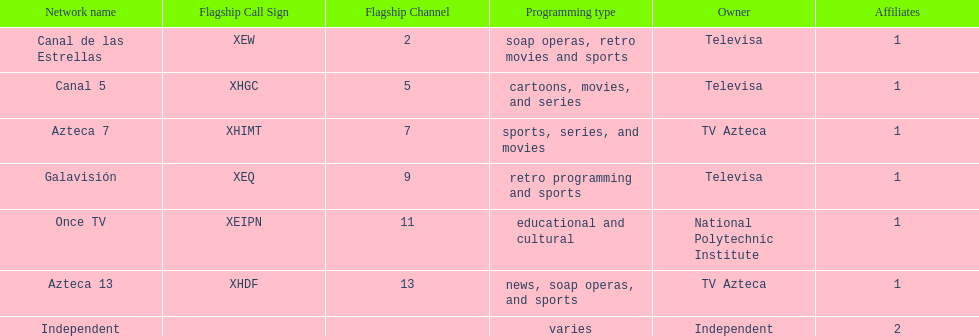How many networks does tv azteca own? 2. 